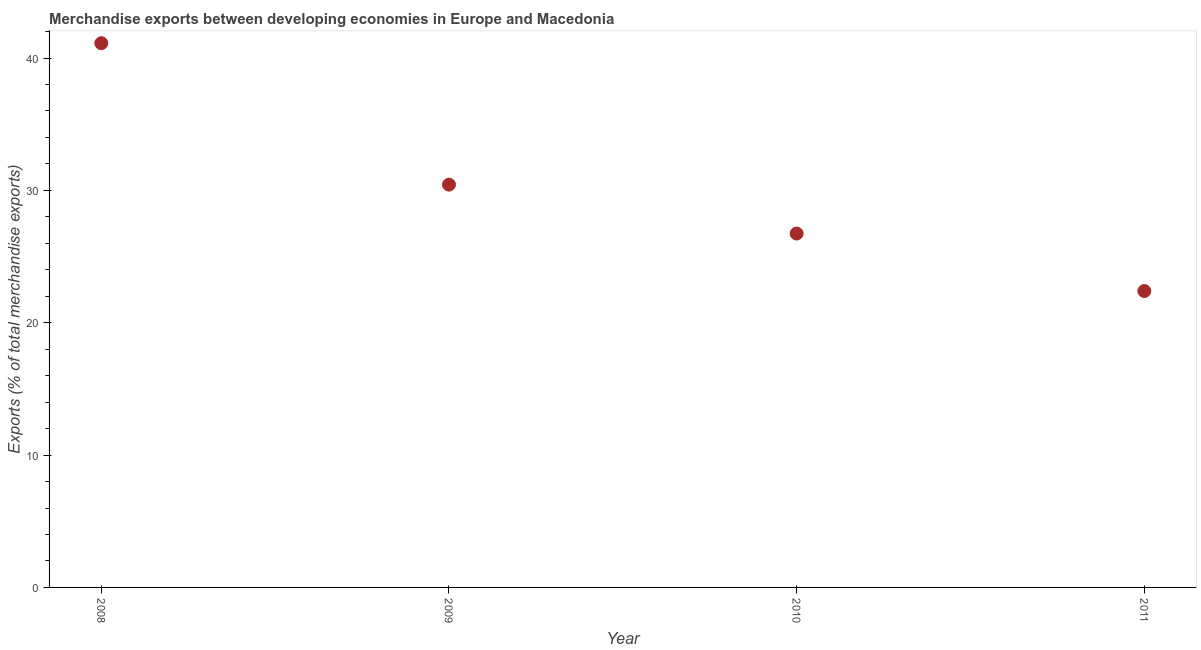What is the merchandise exports in 2011?
Make the answer very short. 22.39. Across all years, what is the maximum merchandise exports?
Offer a terse response. 41.12. Across all years, what is the minimum merchandise exports?
Provide a short and direct response. 22.39. In which year was the merchandise exports maximum?
Keep it short and to the point. 2008. In which year was the merchandise exports minimum?
Your answer should be compact. 2011. What is the sum of the merchandise exports?
Keep it short and to the point. 120.69. What is the difference between the merchandise exports in 2010 and 2011?
Offer a terse response. 4.34. What is the average merchandise exports per year?
Offer a terse response. 30.17. What is the median merchandise exports?
Offer a terse response. 28.59. Do a majority of the years between 2010 and 2008 (inclusive) have merchandise exports greater than 12 %?
Offer a very short reply. No. What is the ratio of the merchandise exports in 2008 to that in 2009?
Give a very brief answer. 1.35. Is the difference between the merchandise exports in 2008 and 2010 greater than the difference between any two years?
Keep it short and to the point. No. What is the difference between the highest and the second highest merchandise exports?
Your answer should be very brief. 10.68. What is the difference between the highest and the lowest merchandise exports?
Offer a very short reply. 18.73. In how many years, is the merchandise exports greater than the average merchandise exports taken over all years?
Your response must be concise. 2. What is the difference between two consecutive major ticks on the Y-axis?
Provide a succinct answer. 10. Does the graph contain any zero values?
Ensure brevity in your answer.  No. What is the title of the graph?
Offer a very short reply. Merchandise exports between developing economies in Europe and Macedonia. What is the label or title of the X-axis?
Give a very brief answer. Year. What is the label or title of the Y-axis?
Make the answer very short. Exports (% of total merchandise exports). What is the Exports (% of total merchandise exports) in 2008?
Provide a succinct answer. 41.12. What is the Exports (% of total merchandise exports) in 2009?
Offer a very short reply. 30.43. What is the Exports (% of total merchandise exports) in 2010?
Keep it short and to the point. 26.74. What is the Exports (% of total merchandise exports) in 2011?
Offer a terse response. 22.39. What is the difference between the Exports (% of total merchandise exports) in 2008 and 2009?
Make the answer very short. 10.68. What is the difference between the Exports (% of total merchandise exports) in 2008 and 2010?
Offer a very short reply. 14.38. What is the difference between the Exports (% of total merchandise exports) in 2008 and 2011?
Ensure brevity in your answer.  18.73. What is the difference between the Exports (% of total merchandise exports) in 2009 and 2010?
Provide a succinct answer. 3.7. What is the difference between the Exports (% of total merchandise exports) in 2009 and 2011?
Your answer should be compact. 8.04. What is the difference between the Exports (% of total merchandise exports) in 2010 and 2011?
Provide a succinct answer. 4.34. What is the ratio of the Exports (% of total merchandise exports) in 2008 to that in 2009?
Your answer should be very brief. 1.35. What is the ratio of the Exports (% of total merchandise exports) in 2008 to that in 2010?
Your response must be concise. 1.54. What is the ratio of the Exports (% of total merchandise exports) in 2008 to that in 2011?
Your answer should be compact. 1.84. What is the ratio of the Exports (% of total merchandise exports) in 2009 to that in 2010?
Offer a very short reply. 1.14. What is the ratio of the Exports (% of total merchandise exports) in 2009 to that in 2011?
Your answer should be compact. 1.36. What is the ratio of the Exports (% of total merchandise exports) in 2010 to that in 2011?
Keep it short and to the point. 1.19. 